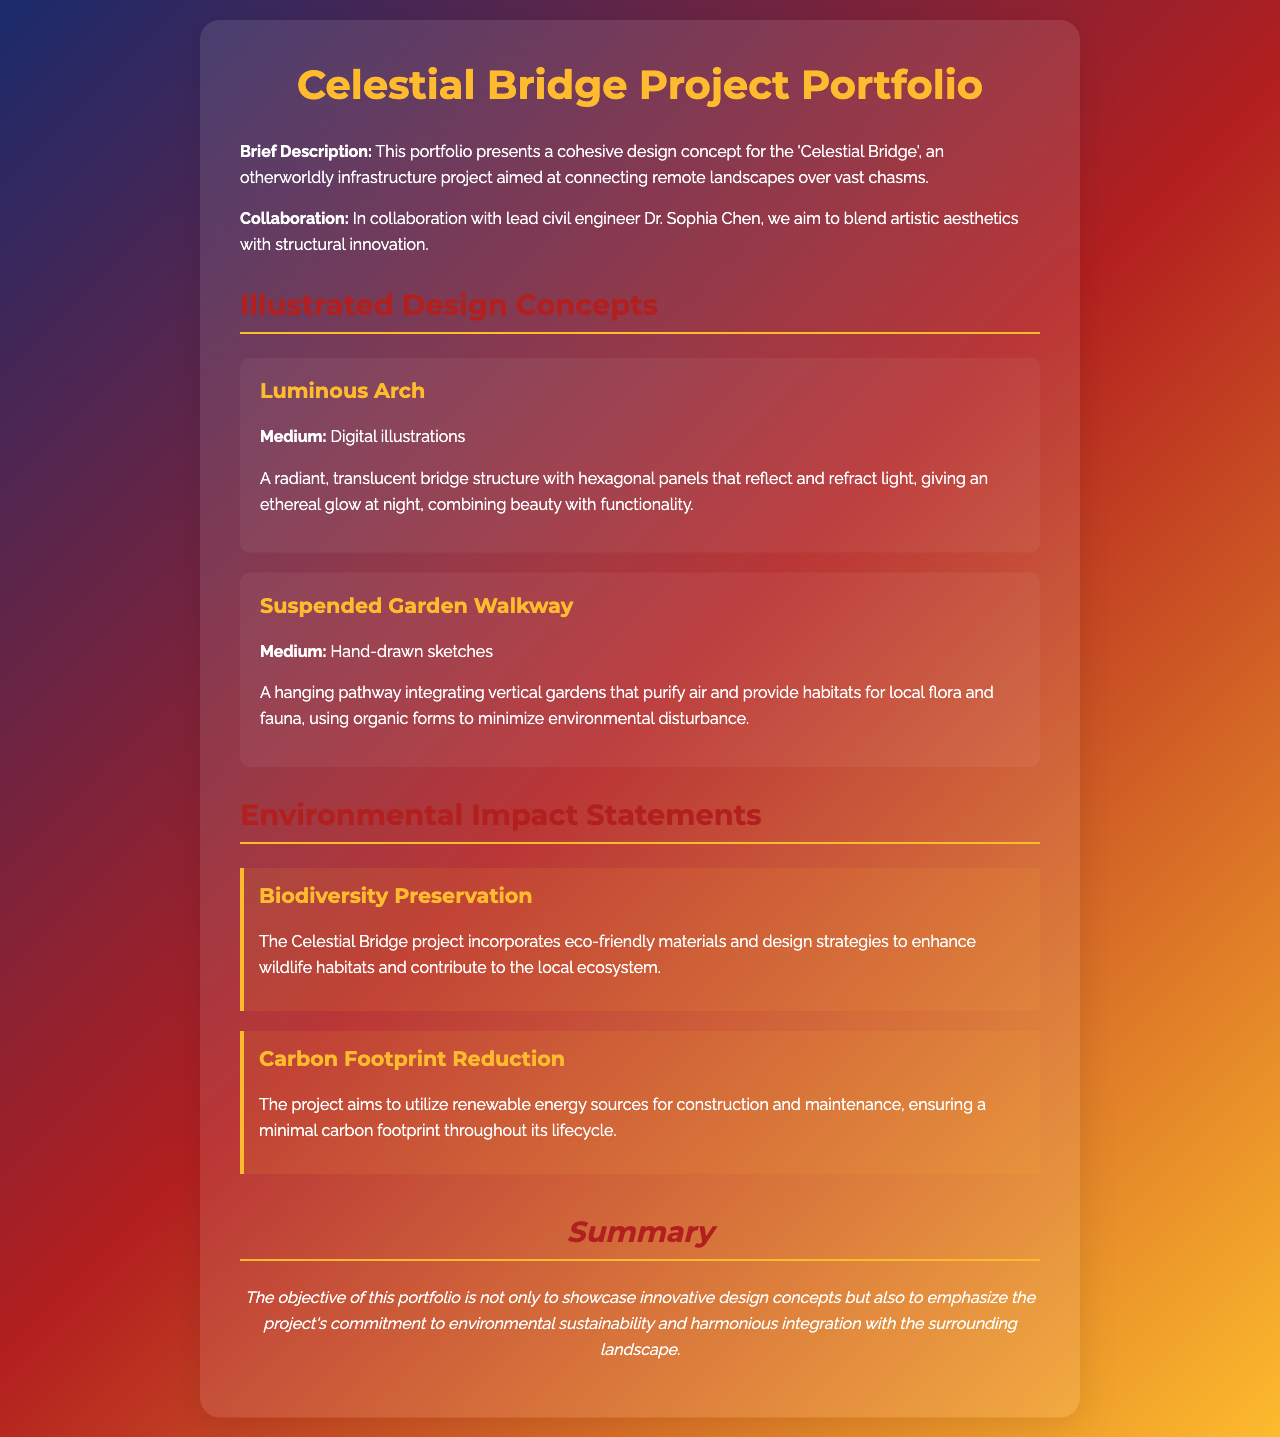What is the title of the project portfolio? The title of the project portfolio is presented prominently at the top of the document.
Answer: Celestial Bridge Project Portfolio Who collaborated with the graphic designer on this project? The document lists the collaborator, a lead civil engineer, under the collaboration section.
Answer: Dr. Sophia Chen What is the medium used for the design concept "Luminous Arch"? The medium for "Luminous Arch" is specified within the description of the illustrated design concepts section.
Answer: Digital illustrations How many illustrated design concepts are presented in the portfolio? The number of concepts can be counted in the illustrated design concepts section of the document.
Answer: Two What environmental impact statement mentions wildlife habitats? The specific environmental impact statement is detailed in the 'Environmental Impact Statements' section.
Answer: Biodiversity Preservation What is one of the goals regarding carbon footprint in the project? The goal is stated clearly under the 'Carbon Footprint Reduction' environmental impact statement.
Answer: Minimal carbon footprint What type of design concept is the "Suspended Garden Walkway"? The type of design concept is categorized in the illustrated design concepts section as well.
Answer: Hand-drawn sketches What color is the title text of the document? The color is specified in the CSS styling for the heading elements.
Answer: #fdbb2d 